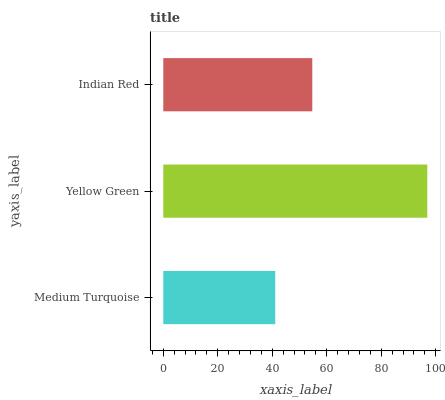Is Medium Turquoise the minimum?
Answer yes or no. Yes. Is Yellow Green the maximum?
Answer yes or no. Yes. Is Indian Red the minimum?
Answer yes or no. No. Is Indian Red the maximum?
Answer yes or no. No. Is Yellow Green greater than Indian Red?
Answer yes or no. Yes. Is Indian Red less than Yellow Green?
Answer yes or no. Yes. Is Indian Red greater than Yellow Green?
Answer yes or no. No. Is Yellow Green less than Indian Red?
Answer yes or no. No. Is Indian Red the high median?
Answer yes or no. Yes. Is Indian Red the low median?
Answer yes or no. Yes. Is Yellow Green the high median?
Answer yes or no. No. Is Medium Turquoise the low median?
Answer yes or no. No. 